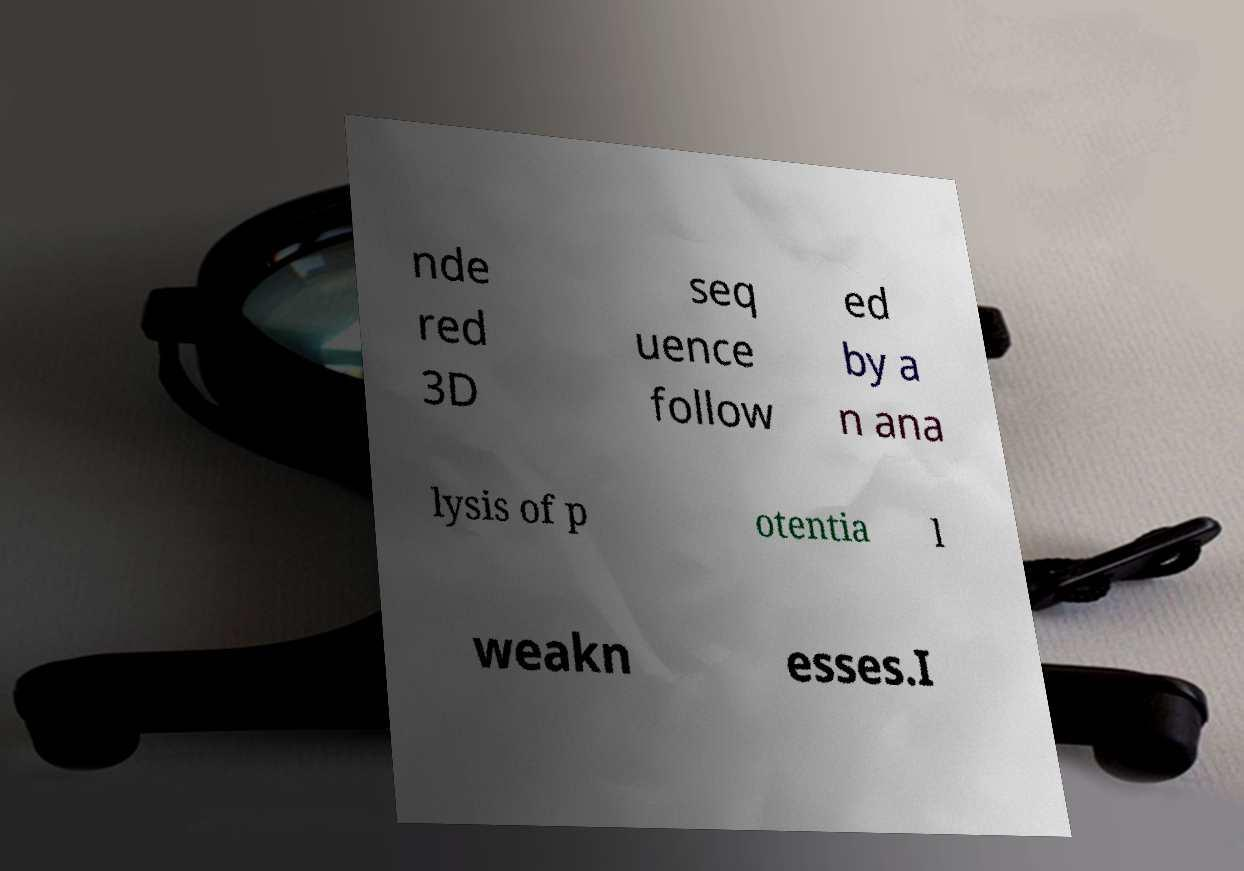What messages or text are displayed in this image? I need them in a readable, typed format. nde red 3D seq uence follow ed by a n ana lysis of p otentia l weakn esses.I 